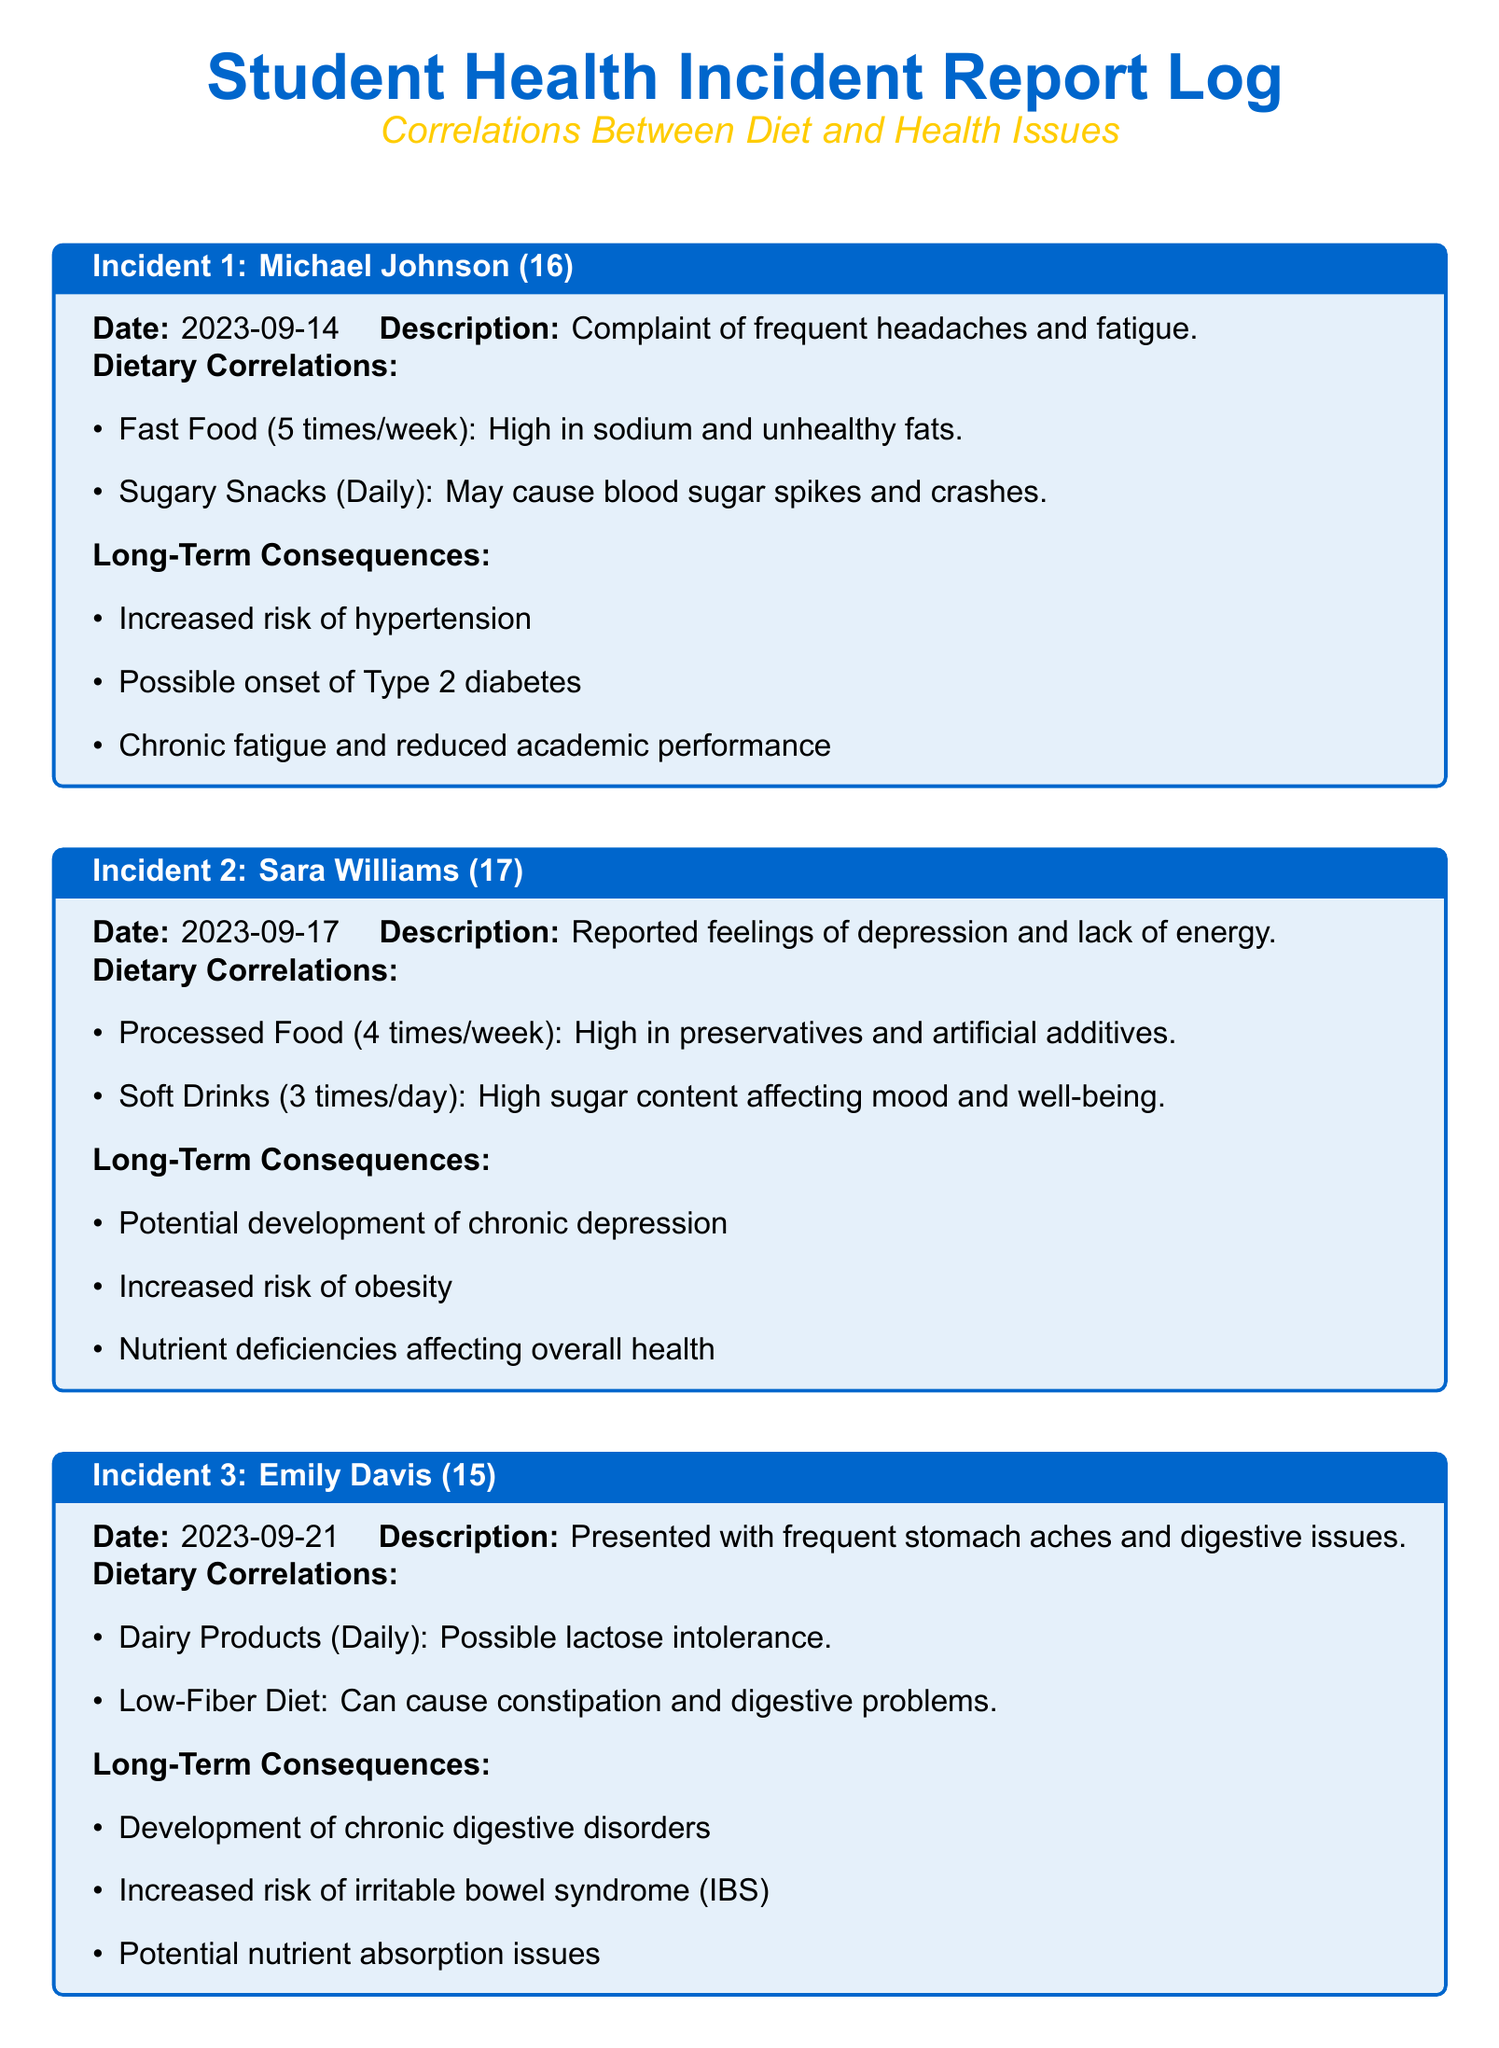What is the name of the first student mentioned in the log? The first student mentioned is Michael Johnson.
Answer: Michael Johnson How many times a week does Michael consume fast food? Michael consumes fast food five times a week, as indicated in the dietary correlations.
Answer: 5 times/week What date was Sara Williams' incident reported? The incident concerning Sara Williams was reported on September 17, 2023.
Answer: 2023-09-17 What type of food is linked to Emily Davis's digestive issues? Emily Davis's digestive issues are linked to dairy products, which she consumes daily.
Answer: Dairy Products What are the long-term consequences of Sara's dietary habits? Sara's dietary habits may lead to potential chronic depression and increased risk of obesity, among others.
Answer: Chronic depression, obesity Which health issue may result from a low-fiber diet as indicated for Emily? The low-fiber diet can cause constipation and digestive problems.
Answer: Constipation What is highlighted in the conclusion of the log? The conclusion emphasizes the correlation between unhealthy dietary habits and health issues among students.
Answer: Correlations between unhealthy dietary habits and health issues How many times a day does Sara drink soft drinks? Sara drinks soft drinks three times a day.
Answer: 3 times/day What is the age of the student who presented with frequent stomach aches? Emily Davis, the student with frequent stomach aches, is 15 years old.
Answer: 15 